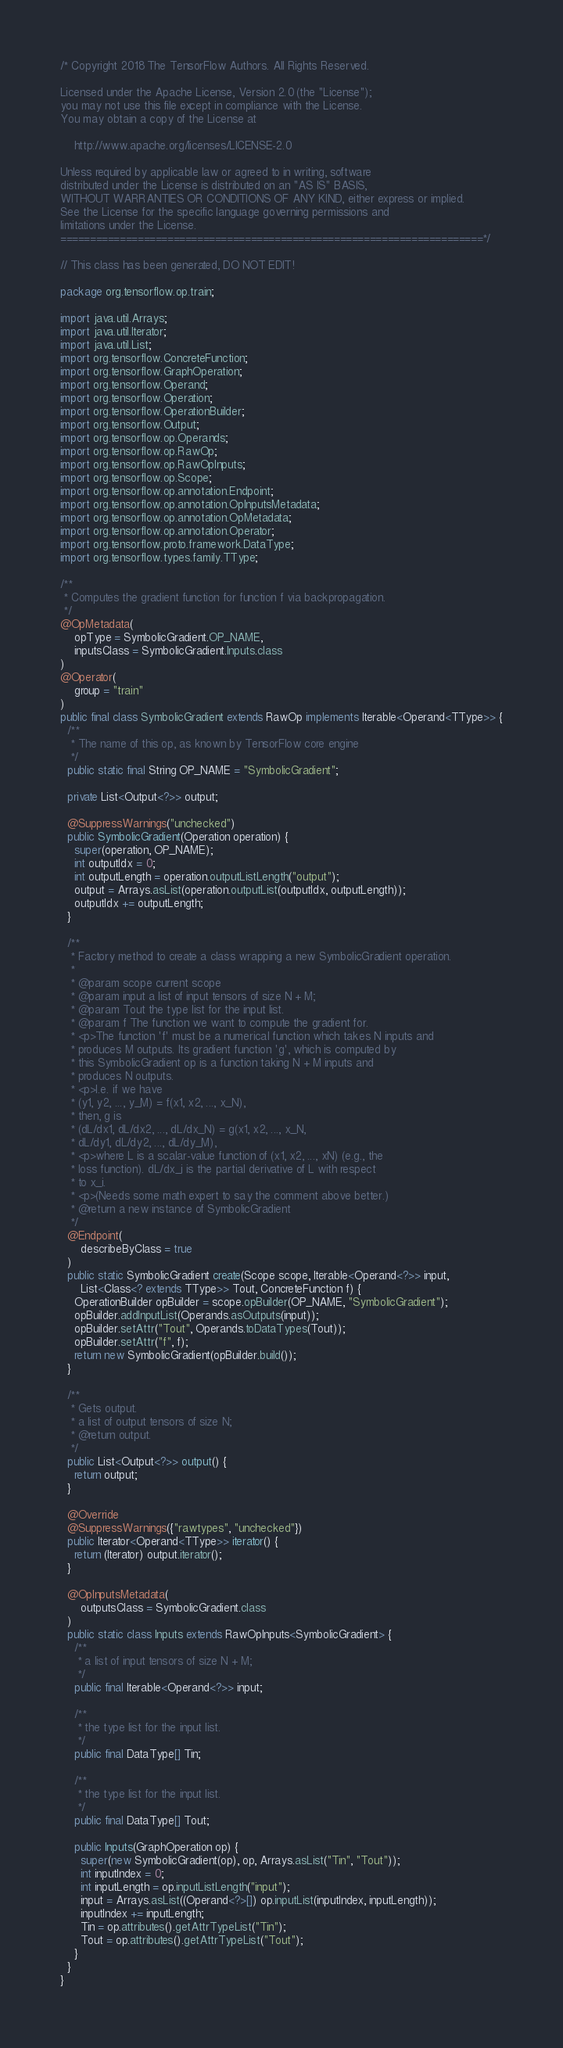Convert code to text. <code><loc_0><loc_0><loc_500><loc_500><_Java_>/* Copyright 2018 The TensorFlow Authors. All Rights Reserved.

Licensed under the Apache License, Version 2.0 (the "License");
you may not use this file except in compliance with the License.
You may obtain a copy of the License at

    http://www.apache.org/licenses/LICENSE-2.0

Unless required by applicable law or agreed to in writing, software
distributed under the License is distributed on an "AS IS" BASIS,
WITHOUT WARRANTIES OR CONDITIONS OF ANY KIND, either express or implied.
See the License for the specific language governing permissions and
limitations under the License.
=======================================================================*/

// This class has been generated, DO NOT EDIT!

package org.tensorflow.op.train;

import java.util.Arrays;
import java.util.Iterator;
import java.util.List;
import org.tensorflow.ConcreteFunction;
import org.tensorflow.GraphOperation;
import org.tensorflow.Operand;
import org.tensorflow.Operation;
import org.tensorflow.OperationBuilder;
import org.tensorflow.Output;
import org.tensorflow.op.Operands;
import org.tensorflow.op.RawOp;
import org.tensorflow.op.RawOpInputs;
import org.tensorflow.op.Scope;
import org.tensorflow.op.annotation.Endpoint;
import org.tensorflow.op.annotation.OpInputsMetadata;
import org.tensorflow.op.annotation.OpMetadata;
import org.tensorflow.op.annotation.Operator;
import org.tensorflow.proto.framework.DataType;
import org.tensorflow.types.family.TType;

/**
 * Computes the gradient function for function f via backpropagation.
 */
@OpMetadata(
    opType = SymbolicGradient.OP_NAME,
    inputsClass = SymbolicGradient.Inputs.class
)
@Operator(
    group = "train"
)
public final class SymbolicGradient extends RawOp implements Iterable<Operand<TType>> {
  /**
   * The name of this op, as known by TensorFlow core engine
   */
  public static final String OP_NAME = "SymbolicGradient";

  private List<Output<?>> output;

  @SuppressWarnings("unchecked")
  public SymbolicGradient(Operation operation) {
    super(operation, OP_NAME);
    int outputIdx = 0;
    int outputLength = operation.outputListLength("output");
    output = Arrays.asList(operation.outputList(outputIdx, outputLength));
    outputIdx += outputLength;
  }

  /**
   * Factory method to create a class wrapping a new SymbolicGradient operation.
   *
   * @param scope current scope
   * @param input a list of input tensors of size N + M;
   * @param Tout the type list for the input list.
   * @param f The function we want to compute the gradient for.
   * <p>The function 'f' must be a numerical function which takes N inputs and
   * produces M outputs. Its gradient function 'g', which is computed by
   * this SymbolicGradient op is a function taking N + M inputs and
   * produces N outputs.
   * <p>I.e. if we have
   * (y1, y2, ..., y_M) = f(x1, x2, ..., x_N),
   * then, g is
   * (dL/dx1, dL/dx2, ..., dL/dx_N) = g(x1, x2, ..., x_N,
   * dL/dy1, dL/dy2, ..., dL/dy_M),
   * <p>where L is a scalar-value function of (x1, x2, ..., xN) (e.g., the
   * loss function). dL/dx_i is the partial derivative of L with respect
   * to x_i.
   * <p>(Needs some math expert to say the comment above better.)
   * @return a new instance of SymbolicGradient
   */
  @Endpoint(
      describeByClass = true
  )
  public static SymbolicGradient create(Scope scope, Iterable<Operand<?>> input,
      List<Class<? extends TType>> Tout, ConcreteFunction f) {
    OperationBuilder opBuilder = scope.opBuilder(OP_NAME, "SymbolicGradient");
    opBuilder.addInputList(Operands.asOutputs(input));
    opBuilder.setAttr("Tout", Operands.toDataTypes(Tout));
    opBuilder.setAttr("f", f);
    return new SymbolicGradient(opBuilder.build());
  }

  /**
   * Gets output.
   * a list of output tensors of size N;
   * @return output.
   */
  public List<Output<?>> output() {
    return output;
  }

  @Override
  @SuppressWarnings({"rawtypes", "unchecked"})
  public Iterator<Operand<TType>> iterator() {
    return (Iterator) output.iterator();
  }

  @OpInputsMetadata(
      outputsClass = SymbolicGradient.class
  )
  public static class Inputs extends RawOpInputs<SymbolicGradient> {
    /**
     * a list of input tensors of size N + M;
     */
    public final Iterable<Operand<?>> input;

    /**
     * the type list for the input list.
     */
    public final DataType[] Tin;

    /**
     * the type list for the input list.
     */
    public final DataType[] Tout;

    public Inputs(GraphOperation op) {
      super(new SymbolicGradient(op), op, Arrays.asList("Tin", "Tout"));
      int inputIndex = 0;
      int inputLength = op.inputListLength("input");
      input = Arrays.asList((Operand<?>[]) op.inputList(inputIndex, inputLength));
      inputIndex += inputLength;
      Tin = op.attributes().getAttrTypeList("Tin");
      Tout = op.attributes().getAttrTypeList("Tout");
    }
  }
}
</code> 